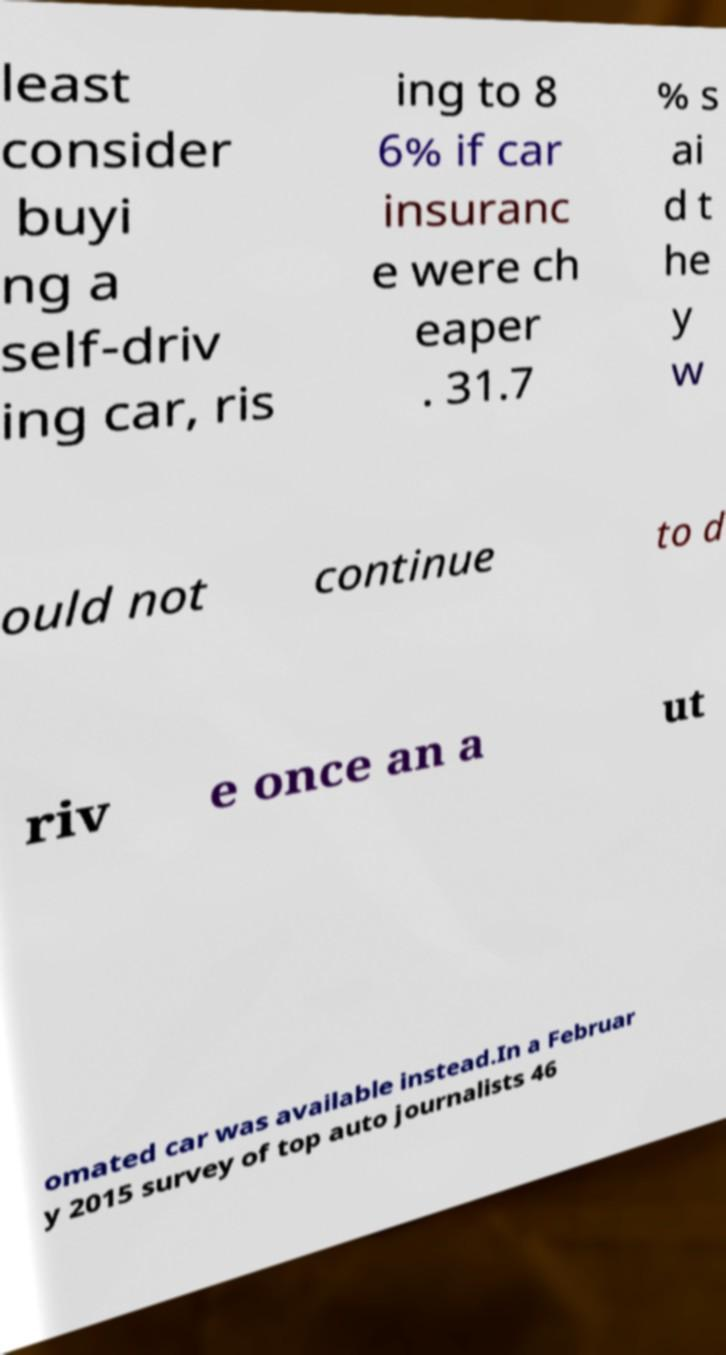Please read and relay the text visible in this image. What does it say? least consider buyi ng a self-driv ing car, ris ing to 8 6% if car insuranc e were ch eaper . 31.7 % s ai d t he y w ould not continue to d riv e once an a ut omated car was available instead.In a Februar y 2015 survey of top auto journalists 46 